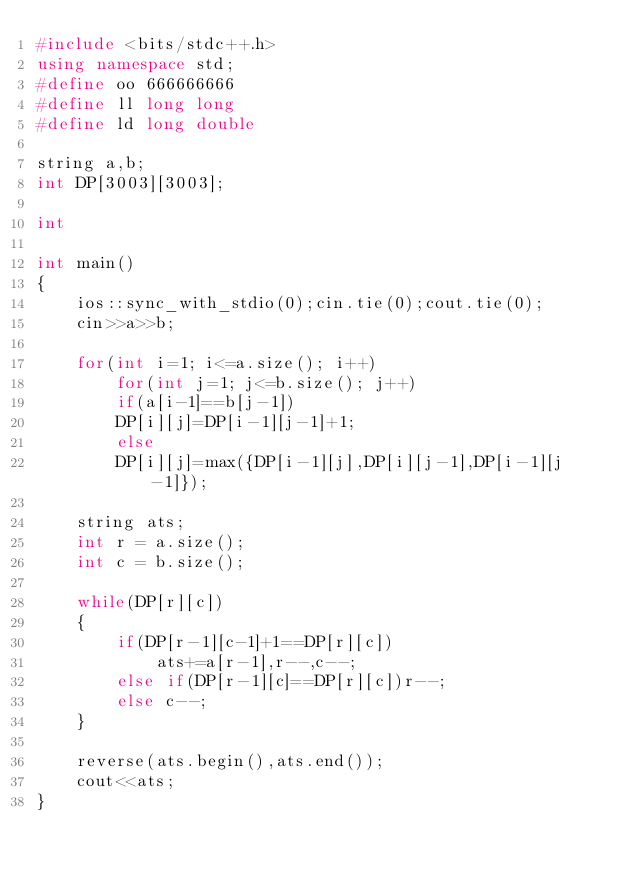<code> <loc_0><loc_0><loc_500><loc_500><_C++_>#include <bits/stdc++.h>
using namespace std;
#define oo 666666666
#define ll long long
#define ld long double

string a,b;
int DP[3003][3003];

int

int main()
{
    ios::sync_with_stdio(0);cin.tie(0);cout.tie(0);
    cin>>a>>b;

    for(int i=1; i<=a.size(); i++)
        for(int j=1; j<=b.size(); j++)
        if(a[i-1]==b[j-1])
        DP[i][j]=DP[i-1][j-1]+1;
        else
        DP[i][j]=max({DP[i-1][j],DP[i][j-1],DP[i-1][j-1]});

    string ats;
    int r = a.size();
    int c = b.size();

    while(DP[r][c])
    {
        if(DP[r-1][c-1]+1==DP[r][c])
            ats+=a[r-1],r--,c--;
        else if(DP[r-1][c]==DP[r][c])r--;
        else c--;
    }

    reverse(ats.begin(),ats.end());
    cout<<ats;
}
</code> 